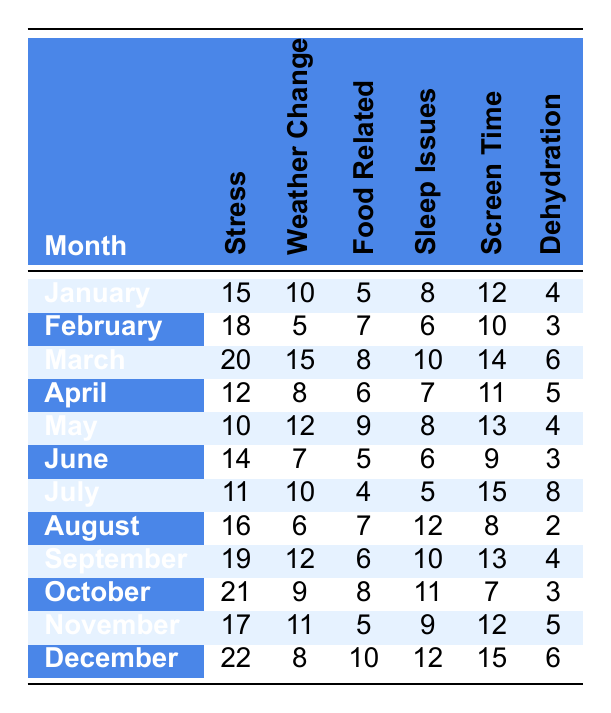What is the highest reported number of stress-related headaches in a month? Looking through the 'Stress' column for each month, the highest value is 22, which occurs in December.
Answer: 22 In which month did food-related headaches have the lowest reported incidents? Reviewing the 'Food Related' column, the minimum value is 4, observed in July.
Answer: July What was the average number of dehydration incidents reported over the entire year? Adding the values for dehydration (4, 3, 6, 5, 4, 3, 8, 2, 4, 3, 5, 6) results in a total of 57. Since there are 12 months, the average is 57/12 = 4.75.
Answer: 4.75 Which month had the second-highest reported incidents of headaches due to screen time? The 'Screen Time' column values in descending order show December (15) as the highest, followed by March (14) as the second-highest.
Answer: March Was there a month where the number of weather-related headache incidents was zero? Inspecting the 'Weather Change' column, all months contain positive reported incidents, so there are no months with zero incidents.
Answer: No What was the total number of headaches reported due to sleep issues for the first half of the year (January to June)? Summing the values for sleep issues from January to June gives (8 + 6 + 10 + 7 + 8 + 6) = 45.
Answer: 45 Which trigger had the highest total of reported incidents across all months? Adding all the values for each trigger: Stress (212), Weather Change (83), Food Related (66), Sleep Issues (77), Screen Time (98), and Dehydration (57). Here, Stress has the highest total at 212.
Answer: Stress How many months had more than 10 incidents reported for sleep issues? Counting the values in the 'Sleep Issues' column, the months that have more than 10 incidents are March (10), July (5), August (12), September (10), October (11), December (12). So there are 4 months with more than 10 incidents.
Answer: 4 Is there any month where stress-related headaches were equal to or greater than 20 incidents? Checking the 'Stress' column, the months where the count is 20 or more are March (20), October (21), and December (22).
Answer: Yes What is the difference in the number of weather change headaches reported between February and June? The values are 5 in February and 7 in June. The difference is 7 - 5 = 2.
Answer: 2 Which month reported the least number of headaches due to food-related triggers? In the 'Food Related' column, the lowest count is 4, found in July.
Answer: July 